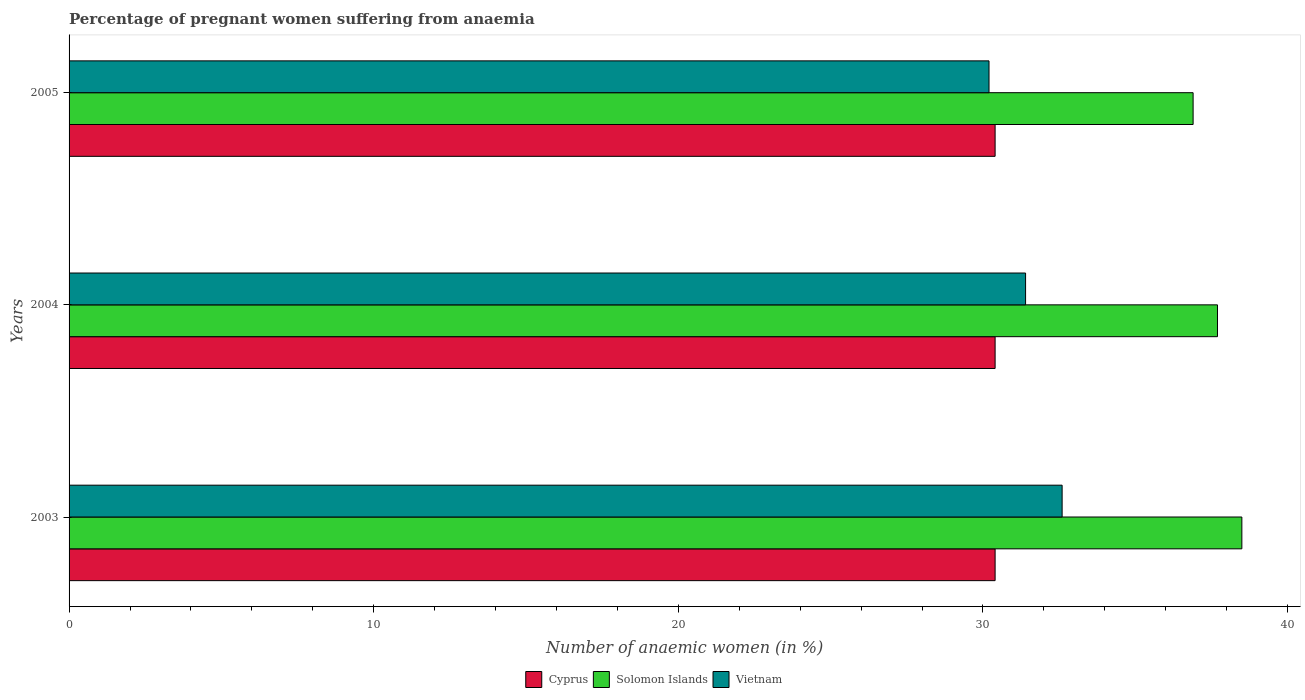How many different coloured bars are there?
Ensure brevity in your answer.  3. How many bars are there on the 1st tick from the bottom?
Make the answer very short. 3. What is the label of the 3rd group of bars from the top?
Provide a succinct answer. 2003. What is the number of anaemic women in Vietnam in 2004?
Your answer should be very brief. 31.4. Across all years, what is the maximum number of anaemic women in Vietnam?
Your response must be concise. 32.6. Across all years, what is the minimum number of anaemic women in Solomon Islands?
Offer a terse response. 36.9. In which year was the number of anaemic women in Cyprus maximum?
Ensure brevity in your answer.  2003. What is the total number of anaemic women in Vietnam in the graph?
Your response must be concise. 94.2. What is the difference between the number of anaemic women in Vietnam in 2003 and that in 2004?
Your response must be concise. 1.2. What is the difference between the number of anaemic women in Cyprus in 2004 and the number of anaemic women in Vietnam in 2003?
Offer a terse response. -2.2. What is the average number of anaemic women in Cyprus per year?
Provide a succinct answer. 30.4. In the year 2003, what is the difference between the number of anaemic women in Vietnam and number of anaemic women in Solomon Islands?
Provide a short and direct response. -5.9. In how many years, is the number of anaemic women in Vietnam greater than 30 %?
Your answer should be very brief. 3. What is the ratio of the number of anaemic women in Cyprus in 2003 to that in 2005?
Your response must be concise. 1. Is the difference between the number of anaemic women in Vietnam in 2003 and 2005 greater than the difference between the number of anaemic women in Solomon Islands in 2003 and 2005?
Keep it short and to the point. Yes. What is the difference between the highest and the lowest number of anaemic women in Solomon Islands?
Offer a terse response. 1.6. Is the sum of the number of anaemic women in Vietnam in 2003 and 2005 greater than the maximum number of anaemic women in Solomon Islands across all years?
Give a very brief answer. Yes. What does the 3rd bar from the top in 2004 represents?
Your answer should be very brief. Cyprus. What does the 3rd bar from the bottom in 2005 represents?
Your answer should be very brief. Vietnam. How many bars are there?
Your response must be concise. 9. Are the values on the major ticks of X-axis written in scientific E-notation?
Keep it short and to the point. No. Does the graph contain any zero values?
Offer a very short reply. No. Does the graph contain grids?
Give a very brief answer. No. Where does the legend appear in the graph?
Your answer should be very brief. Bottom center. How many legend labels are there?
Provide a short and direct response. 3. What is the title of the graph?
Your response must be concise. Percentage of pregnant women suffering from anaemia. Does "Virgin Islands" appear as one of the legend labels in the graph?
Ensure brevity in your answer.  No. What is the label or title of the X-axis?
Make the answer very short. Number of anaemic women (in %). What is the Number of anaemic women (in %) of Cyprus in 2003?
Your response must be concise. 30.4. What is the Number of anaemic women (in %) in Solomon Islands in 2003?
Give a very brief answer. 38.5. What is the Number of anaemic women (in %) of Vietnam in 2003?
Your answer should be compact. 32.6. What is the Number of anaemic women (in %) in Cyprus in 2004?
Ensure brevity in your answer.  30.4. What is the Number of anaemic women (in %) in Solomon Islands in 2004?
Ensure brevity in your answer.  37.7. What is the Number of anaemic women (in %) of Vietnam in 2004?
Keep it short and to the point. 31.4. What is the Number of anaemic women (in %) in Cyprus in 2005?
Provide a short and direct response. 30.4. What is the Number of anaemic women (in %) of Solomon Islands in 2005?
Make the answer very short. 36.9. What is the Number of anaemic women (in %) in Vietnam in 2005?
Your response must be concise. 30.2. Across all years, what is the maximum Number of anaemic women (in %) of Cyprus?
Offer a terse response. 30.4. Across all years, what is the maximum Number of anaemic women (in %) of Solomon Islands?
Your answer should be compact. 38.5. Across all years, what is the maximum Number of anaemic women (in %) of Vietnam?
Keep it short and to the point. 32.6. Across all years, what is the minimum Number of anaemic women (in %) of Cyprus?
Ensure brevity in your answer.  30.4. Across all years, what is the minimum Number of anaemic women (in %) in Solomon Islands?
Your answer should be very brief. 36.9. Across all years, what is the minimum Number of anaemic women (in %) in Vietnam?
Your answer should be compact. 30.2. What is the total Number of anaemic women (in %) of Cyprus in the graph?
Give a very brief answer. 91.2. What is the total Number of anaemic women (in %) in Solomon Islands in the graph?
Provide a succinct answer. 113.1. What is the total Number of anaemic women (in %) in Vietnam in the graph?
Give a very brief answer. 94.2. What is the difference between the Number of anaemic women (in %) in Solomon Islands in 2003 and that in 2005?
Provide a short and direct response. 1.6. What is the difference between the Number of anaemic women (in %) in Cyprus in 2004 and that in 2005?
Provide a succinct answer. 0. What is the difference between the Number of anaemic women (in %) of Cyprus in 2003 and the Number of anaemic women (in %) of Vietnam in 2004?
Keep it short and to the point. -1. What is the difference between the Number of anaemic women (in %) in Solomon Islands in 2003 and the Number of anaemic women (in %) in Vietnam in 2004?
Give a very brief answer. 7.1. What is the difference between the Number of anaemic women (in %) in Cyprus in 2003 and the Number of anaemic women (in %) in Solomon Islands in 2005?
Provide a succinct answer. -6.5. What is the average Number of anaemic women (in %) of Cyprus per year?
Provide a succinct answer. 30.4. What is the average Number of anaemic women (in %) in Solomon Islands per year?
Provide a succinct answer. 37.7. What is the average Number of anaemic women (in %) in Vietnam per year?
Give a very brief answer. 31.4. In the year 2003, what is the difference between the Number of anaemic women (in %) in Cyprus and Number of anaemic women (in %) in Solomon Islands?
Provide a succinct answer. -8.1. In the year 2003, what is the difference between the Number of anaemic women (in %) in Solomon Islands and Number of anaemic women (in %) in Vietnam?
Offer a very short reply. 5.9. In the year 2004, what is the difference between the Number of anaemic women (in %) in Cyprus and Number of anaemic women (in %) in Vietnam?
Your response must be concise. -1. In the year 2005, what is the difference between the Number of anaemic women (in %) in Cyprus and Number of anaemic women (in %) in Solomon Islands?
Provide a succinct answer. -6.5. In the year 2005, what is the difference between the Number of anaemic women (in %) in Cyprus and Number of anaemic women (in %) in Vietnam?
Your answer should be compact. 0.2. In the year 2005, what is the difference between the Number of anaemic women (in %) in Solomon Islands and Number of anaemic women (in %) in Vietnam?
Make the answer very short. 6.7. What is the ratio of the Number of anaemic women (in %) of Cyprus in 2003 to that in 2004?
Offer a very short reply. 1. What is the ratio of the Number of anaemic women (in %) in Solomon Islands in 2003 to that in 2004?
Ensure brevity in your answer.  1.02. What is the ratio of the Number of anaemic women (in %) of Vietnam in 2003 to that in 2004?
Keep it short and to the point. 1.04. What is the ratio of the Number of anaemic women (in %) of Cyprus in 2003 to that in 2005?
Keep it short and to the point. 1. What is the ratio of the Number of anaemic women (in %) in Solomon Islands in 2003 to that in 2005?
Your answer should be compact. 1.04. What is the ratio of the Number of anaemic women (in %) of Vietnam in 2003 to that in 2005?
Offer a very short reply. 1.08. What is the ratio of the Number of anaemic women (in %) in Cyprus in 2004 to that in 2005?
Your answer should be compact. 1. What is the ratio of the Number of anaemic women (in %) of Solomon Islands in 2004 to that in 2005?
Offer a very short reply. 1.02. What is the ratio of the Number of anaemic women (in %) in Vietnam in 2004 to that in 2005?
Keep it short and to the point. 1.04. What is the difference between the highest and the second highest Number of anaemic women (in %) of Solomon Islands?
Provide a succinct answer. 0.8. What is the difference between the highest and the lowest Number of anaemic women (in %) of Solomon Islands?
Ensure brevity in your answer.  1.6. 